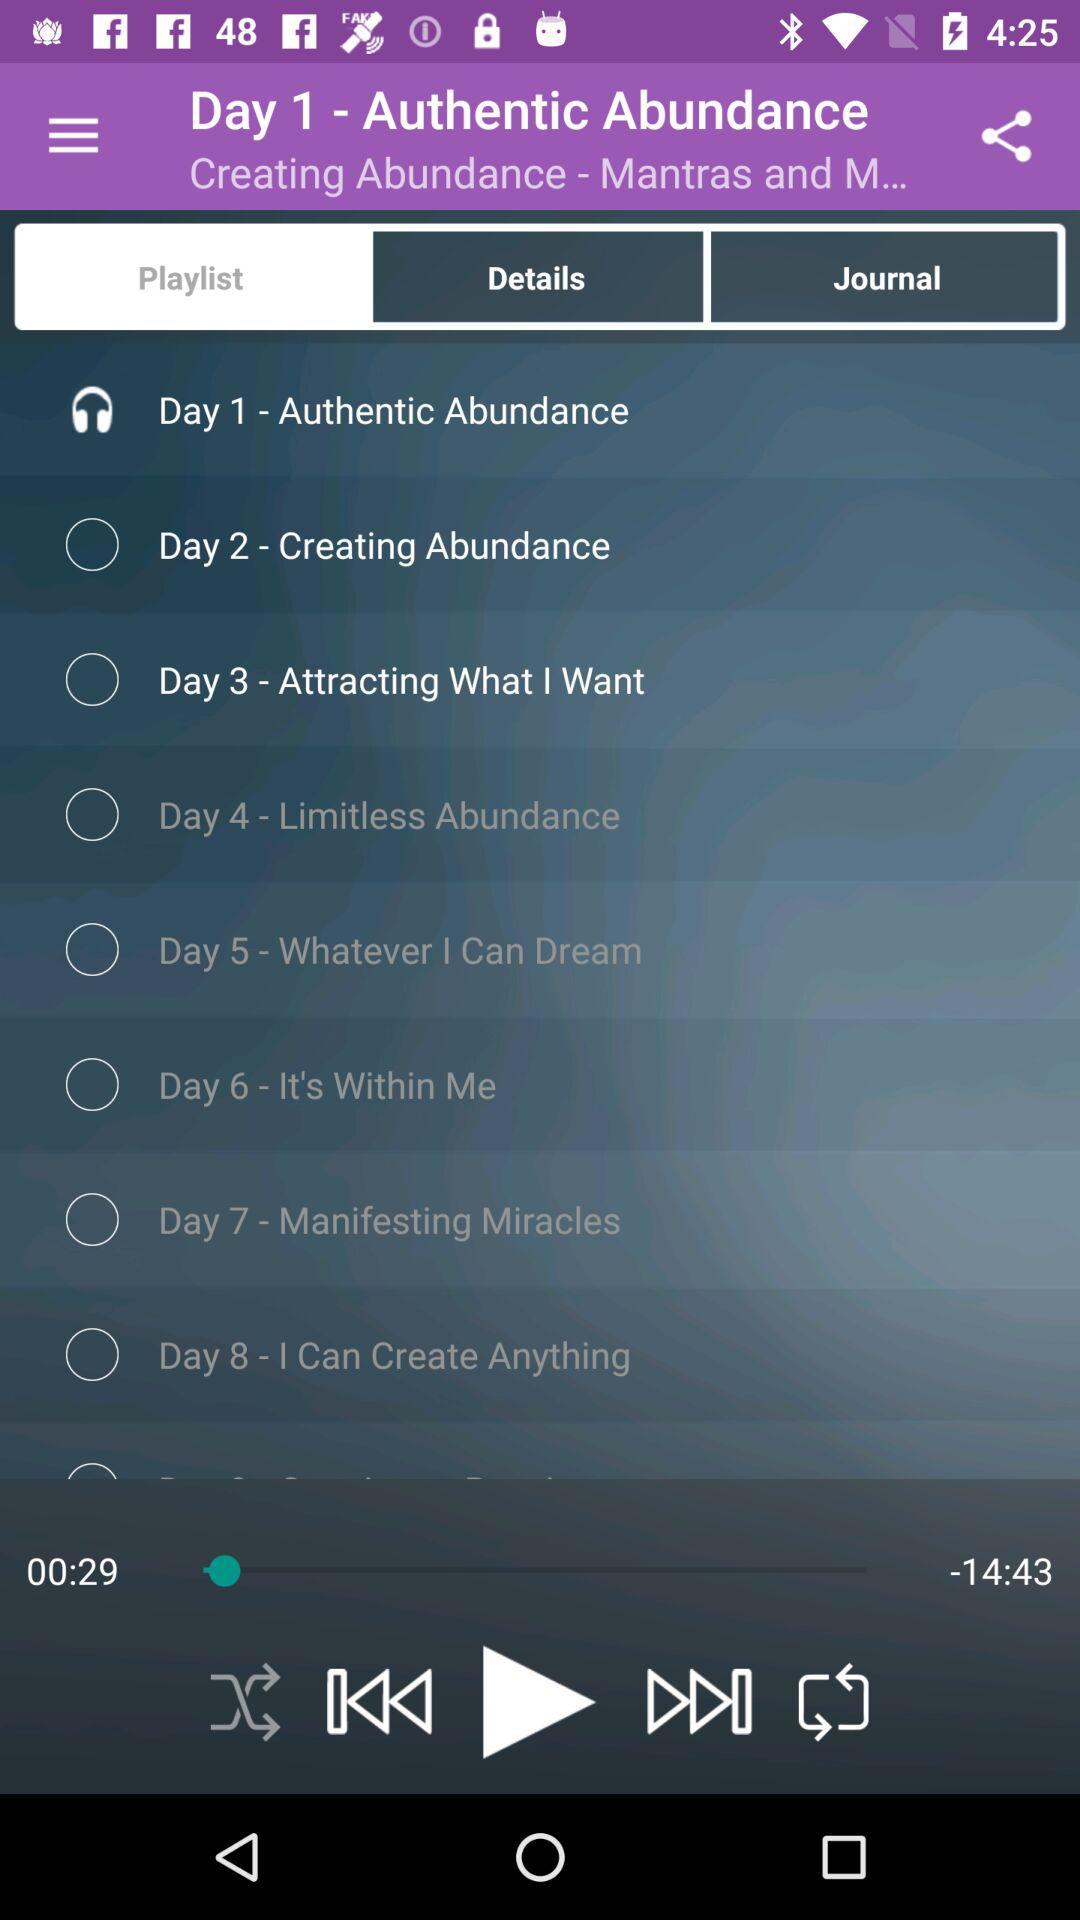What is the remaining duration of the song? The remaining duration of the song is 14 minutes 43 seconds. 